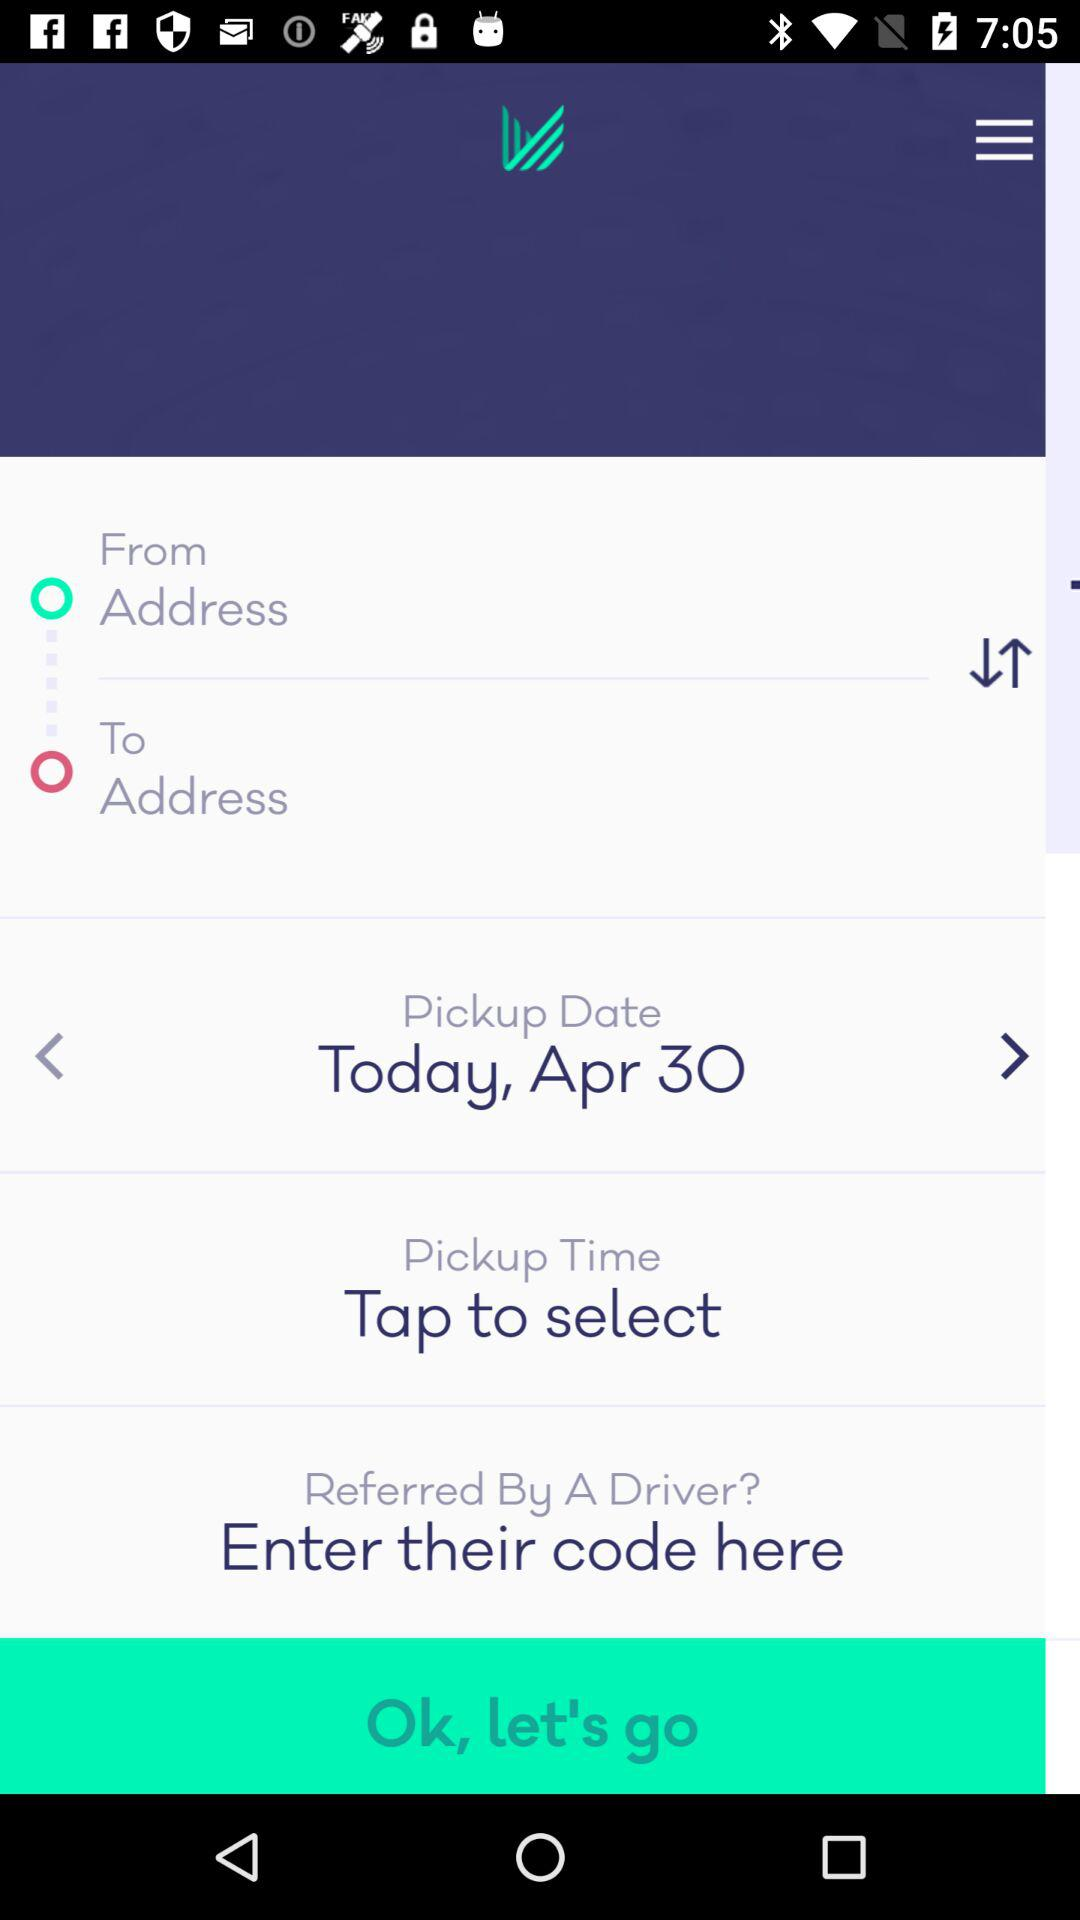What is the pickup time?
When the provided information is insufficient, respond with <no answer>. <no answer> 